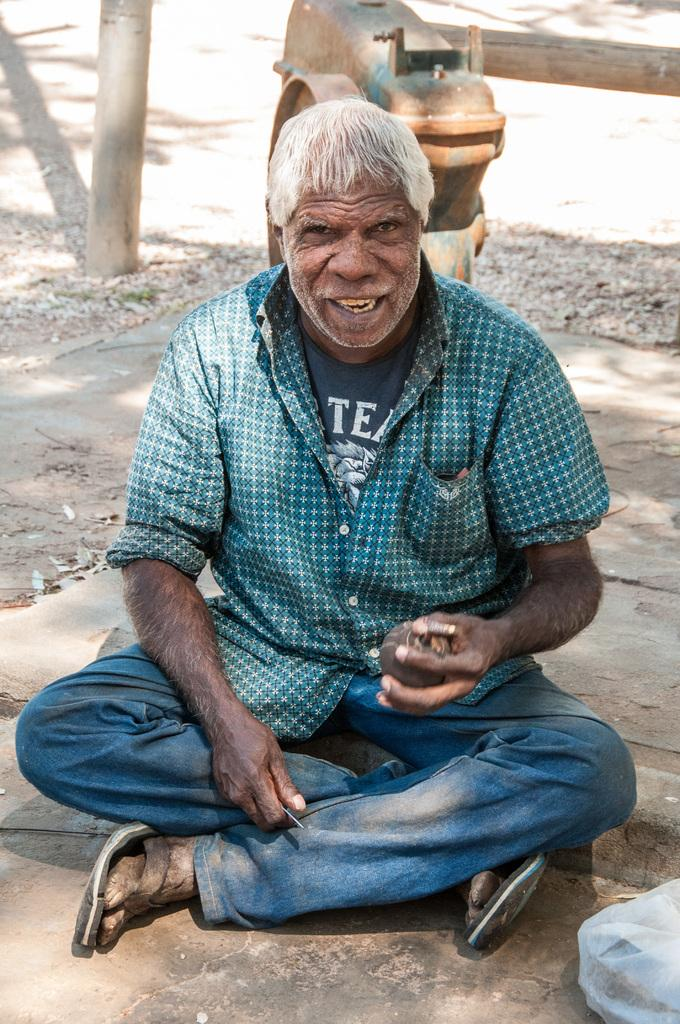Who or what is present in the image? There is a person in the image. What is the person doing in the image? The person is holding an object and sitting on the ground. What can be seen in the background of the image? There is a pole and a machine in the background of the image. How does the person show respect to the machine in the image? There is no indication in the image that the person is showing respect to the machine. The person is simply sitting on the ground and holding an object, and there is no interaction with the machine. 